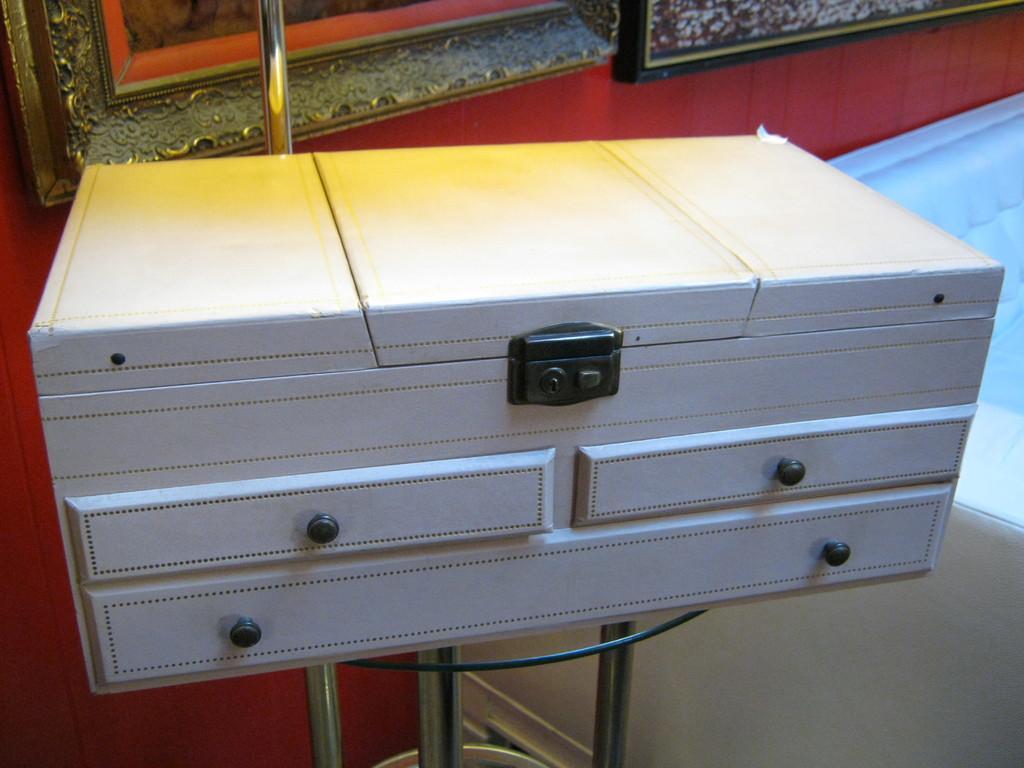Please provide a concise description of this image. In the middle of the picture, we see white color chests of drawers. Behind that, we see a wall in red color and we even see a window. This picture is clicked inside the room. 